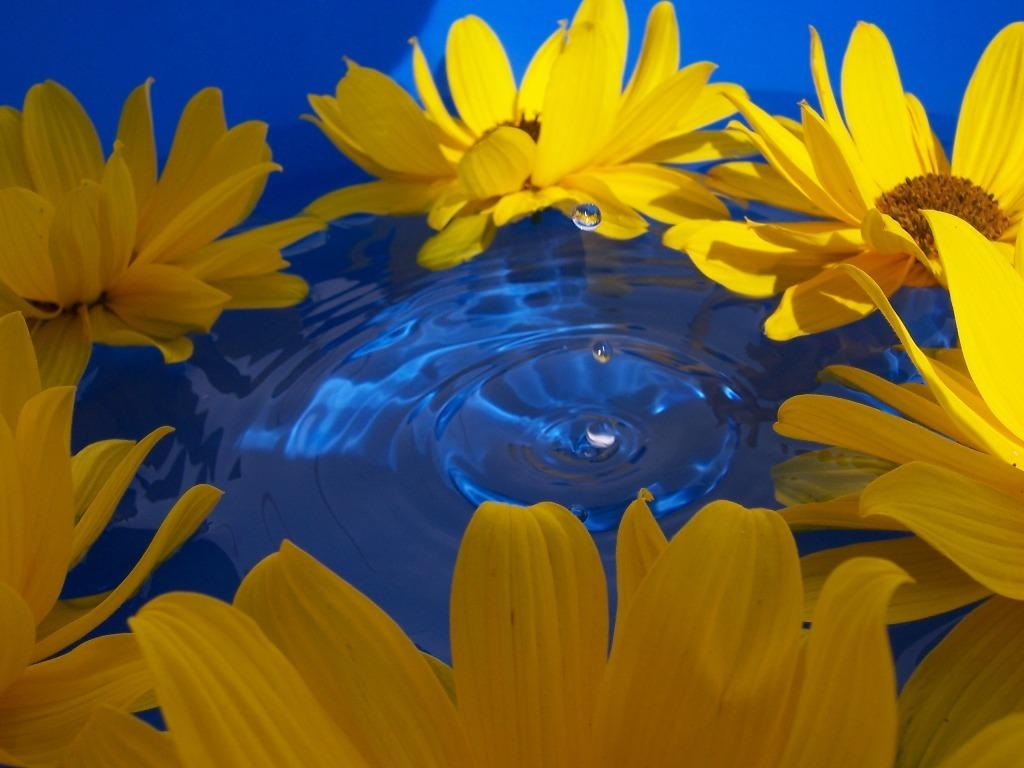What is present on the water in the image? There are many flowers on the water in the image. What can be seen in the middle of the image? There are water drops in the middle of the image. How many birds are perched on the flowers in the image? There are no birds present in the image; it features flowers on the water and water drops. What type of cherry is visible in the image? There is no cherry present in the image. 